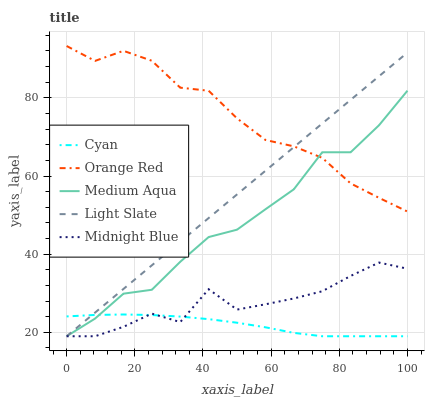Does Cyan have the minimum area under the curve?
Answer yes or no. Yes. Does Orange Red have the maximum area under the curve?
Answer yes or no. Yes. Does Medium Aqua have the minimum area under the curve?
Answer yes or no. No. Does Medium Aqua have the maximum area under the curve?
Answer yes or no. No. Is Light Slate the smoothest?
Answer yes or no. Yes. Is Midnight Blue the roughest?
Answer yes or no. Yes. Is Cyan the smoothest?
Answer yes or no. No. Is Cyan the roughest?
Answer yes or no. No. Does Light Slate have the lowest value?
Answer yes or no. Yes. Does Orange Red have the lowest value?
Answer yes or no. No. Does Orange Red have the highest value?
Answer yes or no. Yes. Does Medium Aqua have the highest value?
Answer yes or no. No. Is Midnight Blue less than Orange Red?
Answer yes or no. Yes. Is Orange Red greater than Cyan?
Answer yes or no. Yes. Does Medium Aqua intersect Midnight Blue?
Answer yes or no. Yes. Is Medium Aqua less than Midnight Blue?
Answer yes or no. No. Is Medium Aqua greater than Midnight Blue?
Answer yes or no. No. Does Midnight Blue intersect Orange Red?
Answer yes or no. No. 